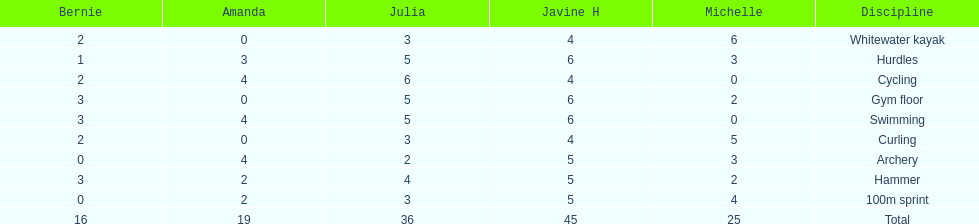Parse the full table. {'header': ['Bernie', 'Amanda', 'Julia', 'Javine H', 'Michelle', 'Discipline'], 'rows': [['2', '0', '3', '4', '6', 'Whitewater kayak'], ['1', '3', '5', '6', '3', 'Hurdles'], ['2', '4', '6', '4', '0', 'Cycling'], ['3', '0', '5', '6', '2', 'Gym floor'], ['3', '4', '5', '6', '0', 'Swimming'], ['2', '0', '3', '4', '5', 'Curling'], ['0', '4', '2', '5', '3', 'Archery'], ['3', '2', '4', '5', '2', 'Hammer'], ['0', '2', '3', '5', '4', '100m sprint'], ['16', '19', '36', '45', '25', 'Total']]} What is the first discipline listed on this chart? Whitewater kayak. 